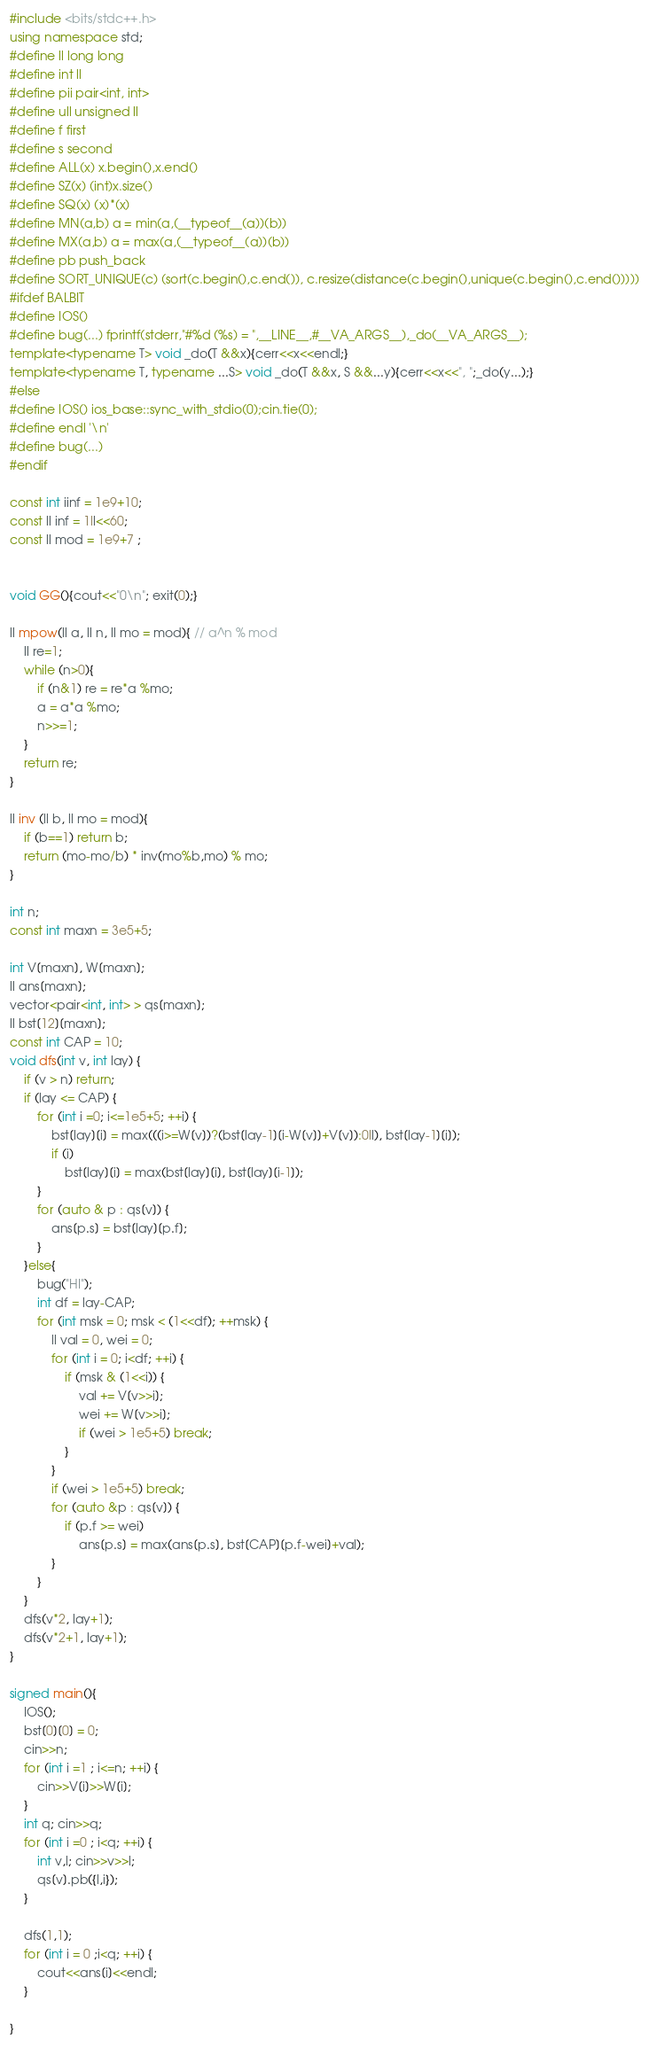Convert code to text. <code><loc_0><loc_0><loc_500><loc_500><_C++_>#include <bits/stdc++.h>
using namespace std;
#define ll long long
#define int ll
#define pii pair<int, int>
#define ull unsigned ll
#define f first
#define s second
#define ALL(x) x.begin(),x.end()
#define SZ(x) (int)x.size()
#define SQ(x) (x)*(x)
#define MN(a,b) a = min(a,(__typeof__(a))(b))
#define MX(a,b) a = max(a,(__typeof__(a))(b))
#define pb push_back
#define SORT_UNIQUE(c) (sort(c.begin(),c.end()), c.resize(distance(c.begin(),unique(c.begin(),c.end()))))
#ifdef BALBIT
#define IOS()
#define bug(...) fprintf(stderr,"#%d (%s) = ",__LINE__,#__VA_ARGS__),_do(__VA_ARGS__);
template<typename T> void _do(T &&x){cerr<<x<<endl;}
template<typename T, typename ...S> void _do(T &&x, S &&...y){cerr<<x<<", ";_do(y...);}
#else
#define IOS() ios_base::sync_with_stdio(0);cin.tie(0);
#define endl '\n'
#define bug(...)
#endif

const int iinf = 1e9+10;
const ll inf = 1ll<<60;
const ll mod = 1e9+7 ;


void GG(){cout<<"0\n"; exit(0);}

ll mpow(ll a, ll n, ll mo = mod){ // a^n % mod
    ll re=1;
    while (n>0){
        if (n&1) re = re*a %mo;
        a = a*a %mo;
        n>>=1;
    }
    return re;
}

ll inv (ll b, ll mo = mod){
    if (b==1) return b;
    return (mo-mo/b) * inv(mo%b,mo) % mo;
}

int n;
const int maxn = 3e5+5;

int V[maxn], W[maxn];
ll ans[maxn];
vector<pair<int, int> > qs[maxn];
ll bst[12][maxn];
const int CAP = 10;
void dfs(int v, int lay) {
    if (v > n) return;
    if (lay <= CAP) {
        for (int i =0; i<=1e5+5; ++i) {
            bst[lay][i] = max(((i>=W[v])?(bst[lay-1][i-W[v]]+V[v]):0ll), bst[lay-1][i]);
            if (i)
                bst[lay][i] = max(bst[lay][i], bst[lay][i-1]);
        }
        for (auto & p : qs[v]) {
            ans[p.s] = bst[lay][p.f];
        }
    }else{
        bug("HI");
        int df = lay-CAP;
        for (int msk = 0; msk < (1<<df); ++msk) {
            ll val = 0, wei = 0;
            for (int i = 0; i<df; ++i) {
                if (msk & (1<<i)) {
                    val += V[v>>i];
                    wei += W[v>>i];
                    if (wei > 1e5+5) break;
                }
            }
            if (wei > 1e5+5) break;
            for (auto &p : qs[v]) {
                if (p.f >= wei)
                    ans[p.s] = max(ans[p.s], bst[CAP][p.f-wei]+val);
            }
        }
    }
    dfs(v*2, lay+1);
    dfs(v*2+1, lay+1);
}

signed main(){
    IOS();
    bst[0][0] = 0;
    cin>>n;
    for (int i =1 ; i<=n; ++i) {
        cin>>V[i]>>W[i];
    }
    int q; cin>>q;
    for (int i =0 ; i<q; ++i) {
        int v,l; cin>>v>>l;
        qs[v].pb({l,i});
    }

    dfs(1,1);
    for (int i = 0 ;i<q; ++i) {
        cout<<ans[i]<<endl;
    }

}
</code> 